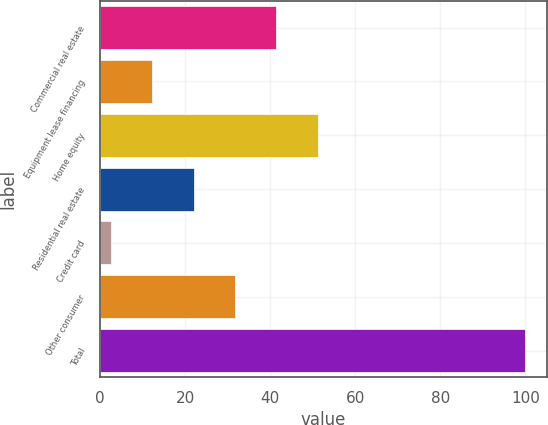Convert chart. <chart><loc_0><loc_0><loc_500><loc_500><bar_chart><fcel>Commercial real estate<fcel>Equipment lease financing<fcel>Home equity<fcel>Residential real estate<fcel>Credit card<fcel>Other consumer<fcel>Total<nl><fcel>41.44<fcel>12.16<fcel>51.2<fcel>21.92<fcel>2.4<fcel>31.68<fcel>100<nl></chart> 